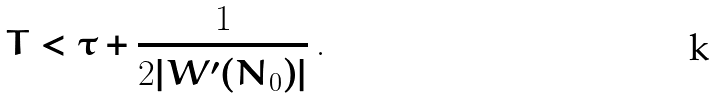<formula> <loc_0><loc_0><loc_500><loc_500>T < \tau + \frac { 1 } { 2 | W ^ { \prime } ( N _ { 0 } ) | } \, .</formula> 